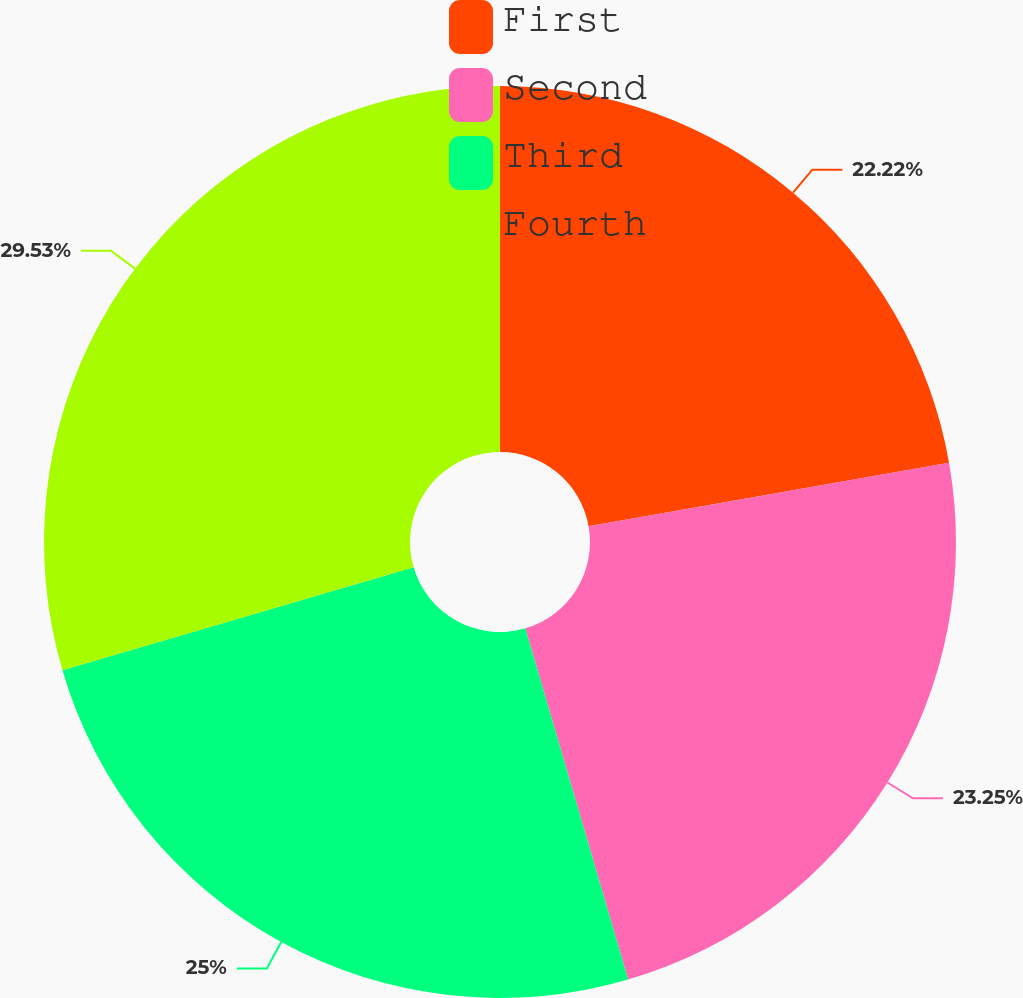Convert chart. <chart><loc_0><loc_0><loc_500><loc_500><pie_chart><fcel>First<fcel>Second<fcel>Third<fcel>Fourth<nl><fcel>22.22%<fcel>23.25%<fcel>25.0%<fcel>29.54%<nl></chart> 